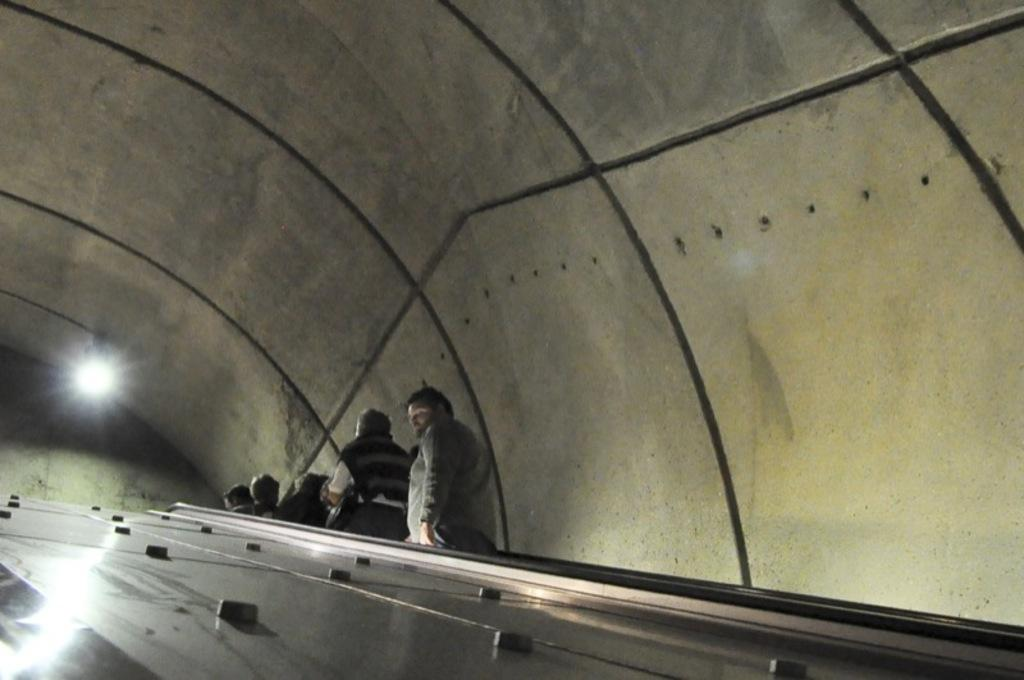What is the main subject of the image? The main subject of the image is a tunnel. What colors are used for the tunnel? The tunnel has a cream and black color. Are there any people present in the image? Yes, there are people standing near the tunnel. Can you describe the lighting in the image? There is a light visible in the image. What material is the tunnel made of? The tunnel has a metal surface. What type of soda is being served in the tunnel? There is no soda present in the image; it features a tunnel with people standing near it. Can you describe the nerve endings of the people standing near the tunnel? There is no information about the nerve endings of the people in the image, as the focus is on the tunnel and its features. 